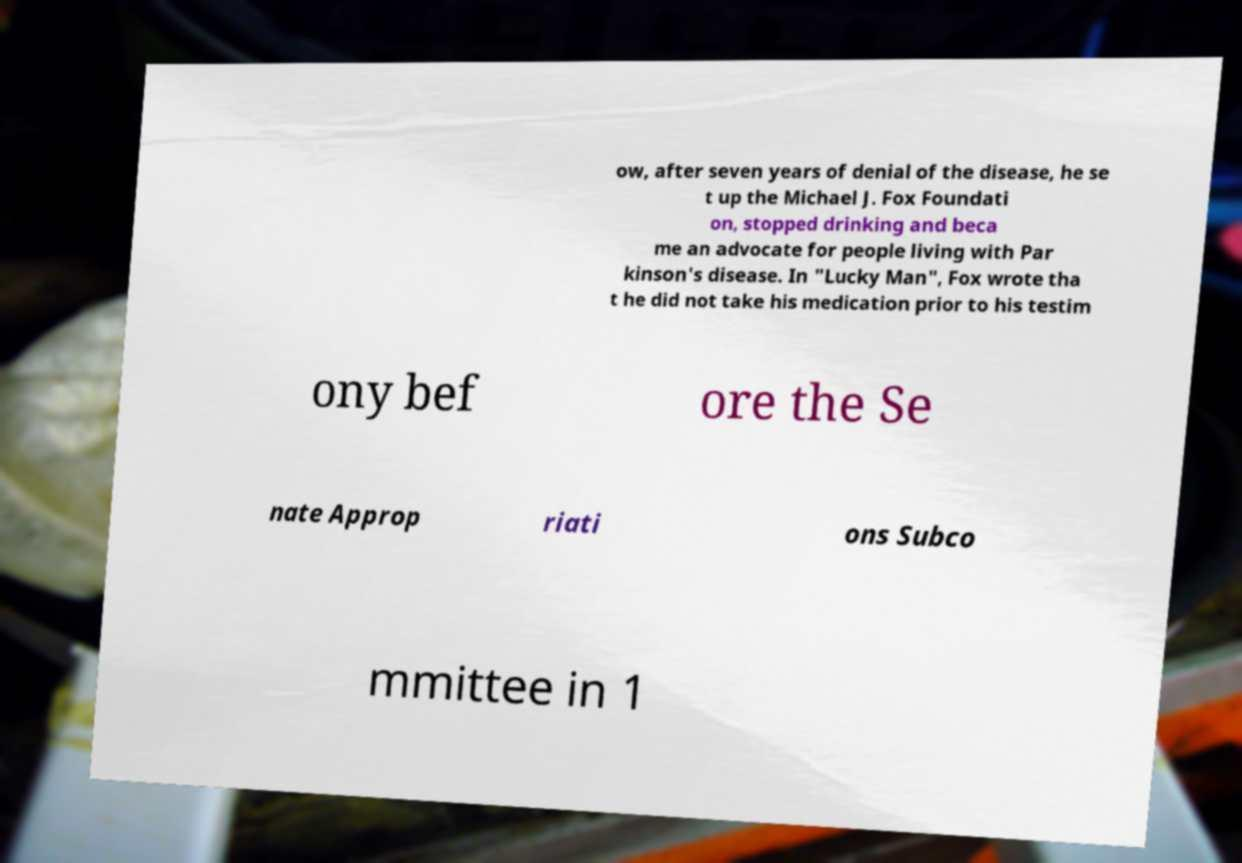I need the written content from this picture converted into text. Can you do that? ow, after seven years of denial of the disease, he se t up the Michael J. Fox Foundati on, stopped drinking and beca me an advocate for people living with Par kinson's disease. In "Lucky Man", Fox wrote tha t he did not take his medication prior to his testim ony bef ore the Se nate Approp riati ons Subco mmittee in 1 